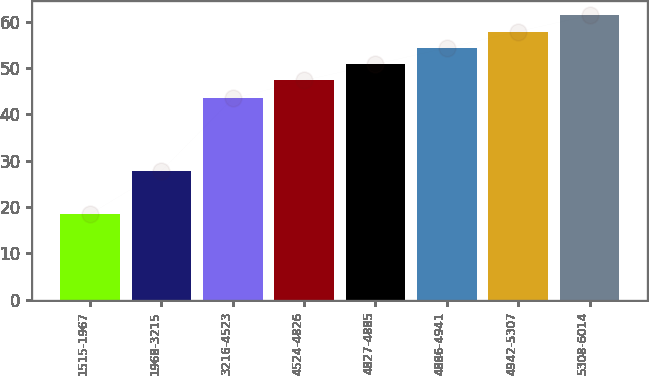Convert chart. <chart><loc_0><loc_0><loc_500><loc_500><bar_chart><fcel>1515-1967<fcel>1968-3215<fcel>3216-4523<fcel>4524-4826<fcel>4827-4885<fcel>4886-4941<fcel>4942-5307<fcel>5308-6014<nl><fcel>18.49<fcel>27.79<fcel>43.44<fcel>47.31<fcel>50.83<fcel>54.35<fcel>57.87<fcel>61.39<nl></chart> 